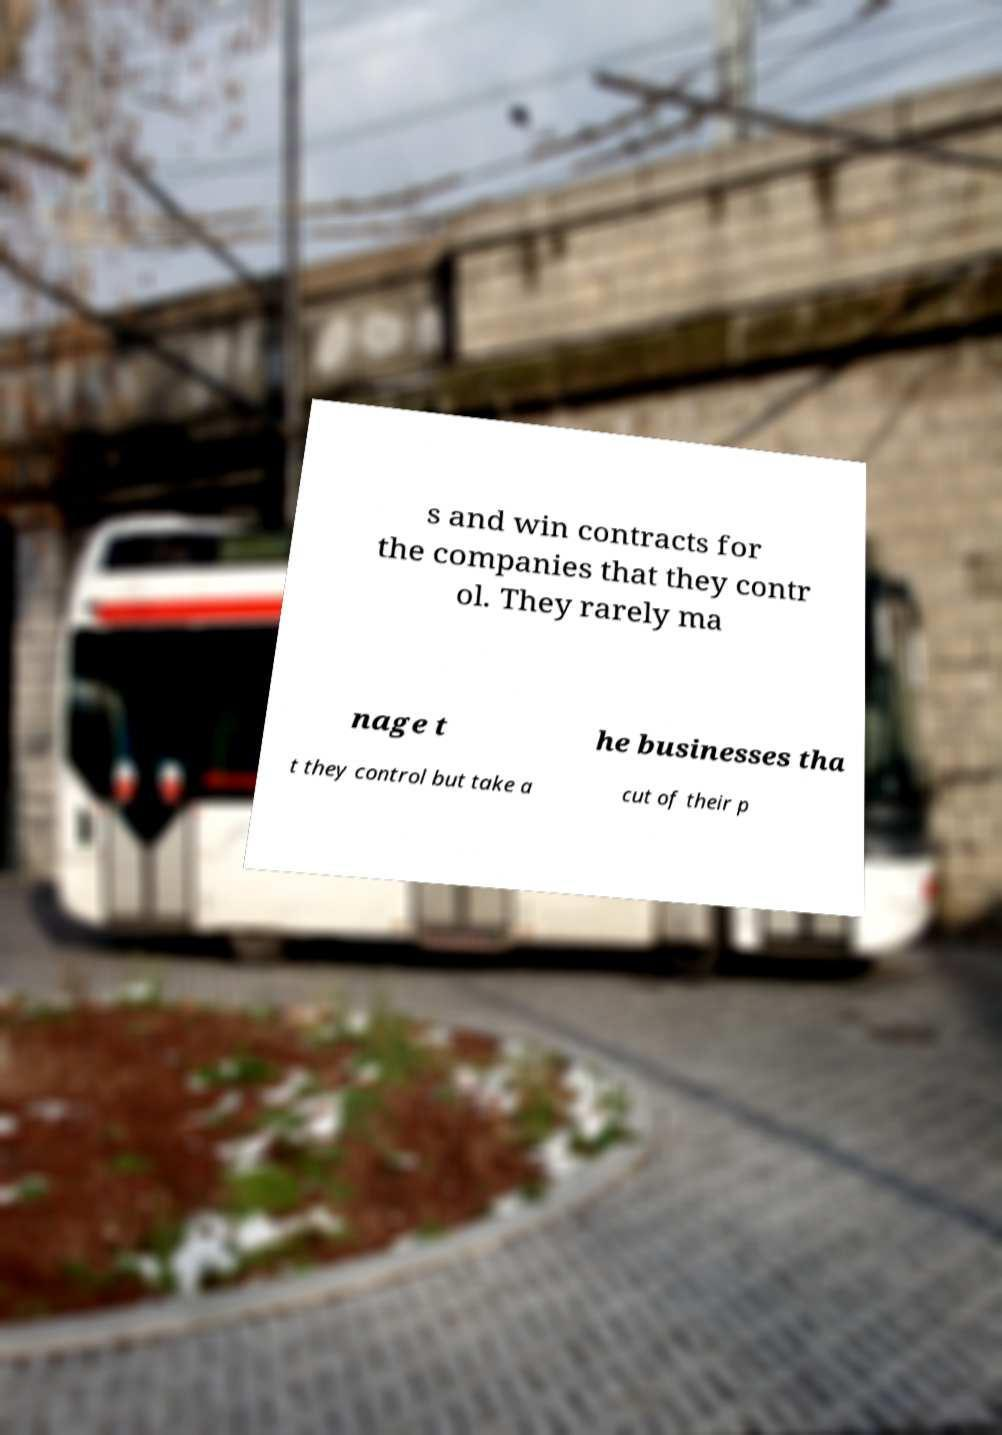For documentation purposes, I need the text within this image transcribed. Could you provide that? s and win contracts for the companies that they contr ol. They rarely ma nage t he businesses tha t they control but take a cut of their p 